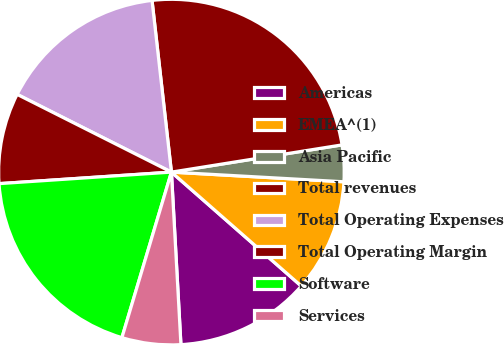Convert chart to OTSL. <chart><loc_0><loc_0><loc_500><loc_500><pie_chart><fcel>Americas<fcel>EMEA^(1)<fcel>Asia Pacific<fcel>Total revenues<fcel>Total Operating Expenses<fcel>Total Operating Margin<fcel>Software<fcel>Services<nl><fcel>12.66%<fcel>10.57%<fcel>3.41%<fcel>24.27%<fcel>15.78%<fcel>8.49%<fcel>19.31%<fcel>5.5%<nl></chart> 